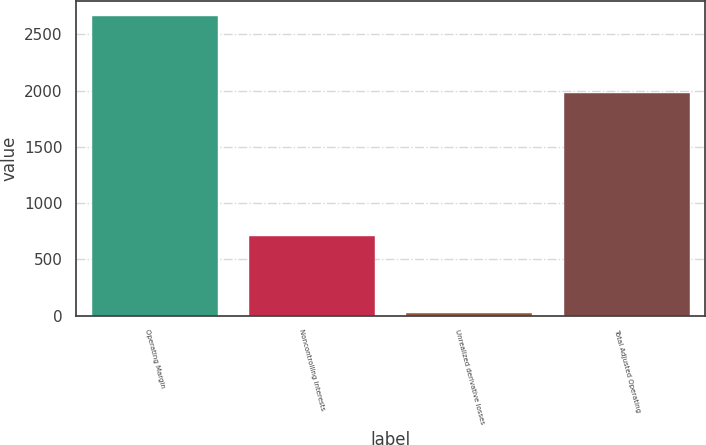<chart> <loc_0><loc_0><loc_500><loc_500><bar_chart><fcel>Operating Margin<fcel>Noncontrolling interests<fcel>Unrealized derivative losses<fcel>Total Adjusted Operating<nl><fcel>2663<fcel>705<fcel>19<fcel>1977<nl></chart> 